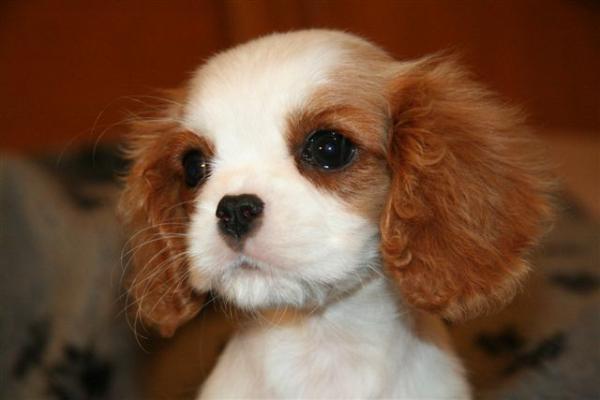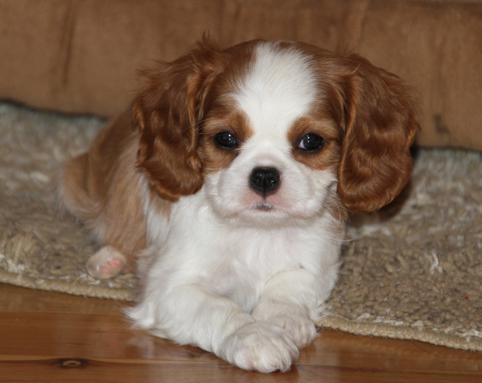The first image is the image on the left, the second image is the image on the right. Given the left and right images, does the statement "An image shows two furry animals side-by-side." hold true? Answer yes or no. No. The first image is the image on the left, the second image is the image on the right. Given the left and right images, does the statement "There are at most two dogs." hold true? Answer yes or no. Yes. The first image is the image on the left, the second image is the image on the right. For the images displayed, is the sentence "There are exactly two animals in the image on the left." factually correct? Answer yes or no. No. The first image is the image on the left, the second image is the image on the right. Evaluate the accuracy of this statement regarding the images: "There are a total of three animals.". Is it true? Answer yes or no. No. 